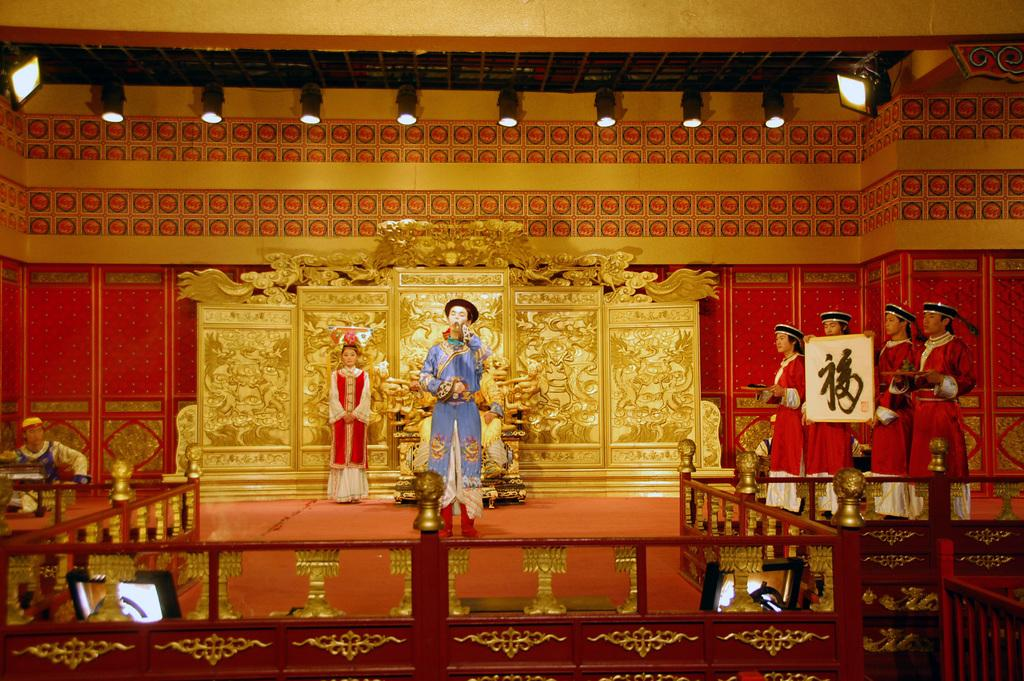How many people are in the image? There is a group of people in the image. What are the people wearing? The people are wearing fancy dresses. What is in front of the people? There is a fence in front of the people. What is behind the people? There is a gold object and a wall behind the people. What type of nerve can be seen in the image? There is no nerve present in the image. What answer is being given by the people in the image? The image does not show the people giving any answers; they are simply standing in front of a fence. 